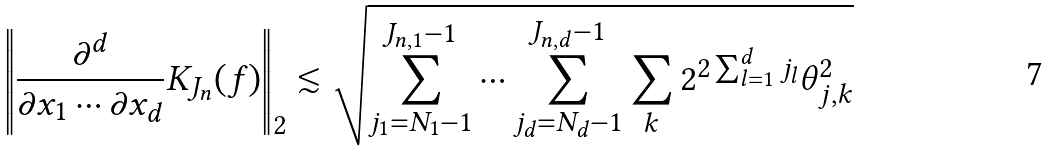<formula> <loc_0><loc_0><loc_500><loc_500>\left \| \frac { \partial ^ { d } } { \partial x _ { 1 } \cdots \partial x _ { d } } K _ { J _ { n } } ( f ) \right \| _ { 2 } \lesssim \sqrt { \sum _ { j _ { 1 } = N _ { 1 } - 1 } ^ { J _ { n , 1 } - 1 } \cdots \sum _ { j _ { d } = N _ { d } - 1 } ^ { J _ { n , d } - 1 } \sum _ { k } 2 ^ { 2 \sum _ { l = 1 } ^ { d } j _ { l } } \theta _ { j , k } ^ { 2 } }</formula> 